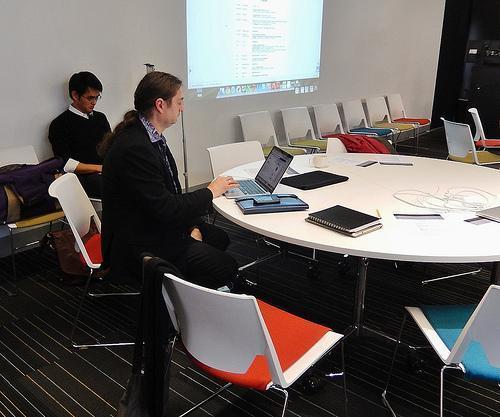How many people are in the picture?
Give a very brief answer. 2. 